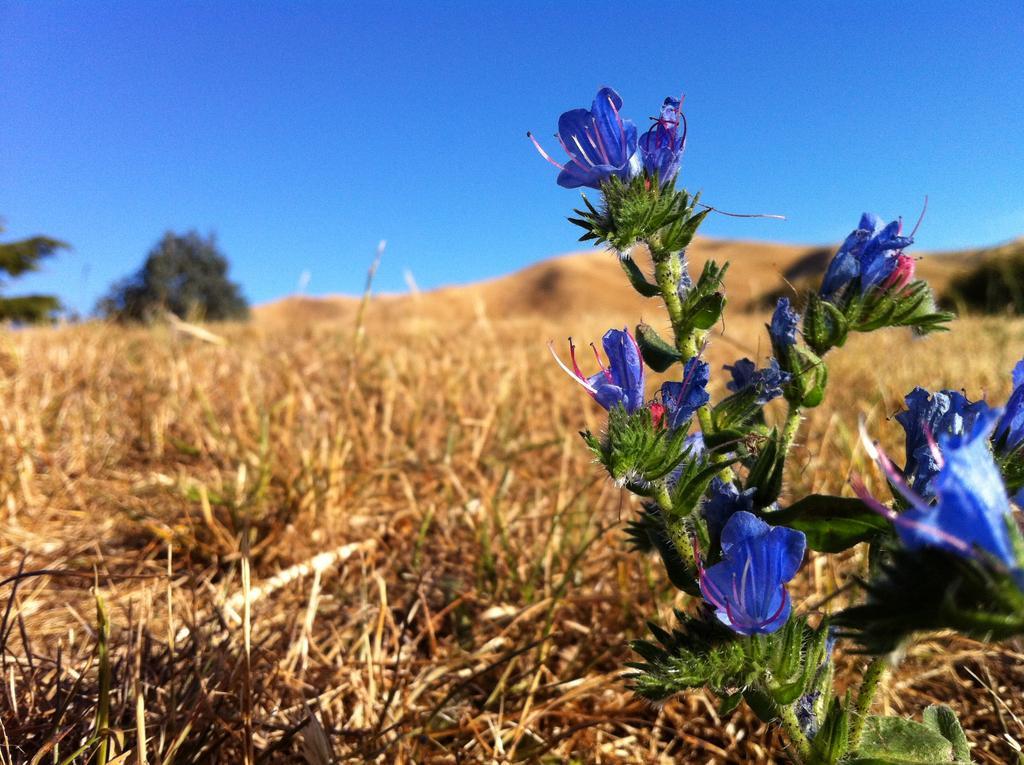Describe this image in one or two sentences. On the right side there are blue color flowers on a stem. On the ground there is grass. In the background there is tree and sky. 